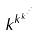<formula> <loc_0><loc_0><loc_500><loc_500>k ^ { k ^ { k ^ { \cdot ^ { \cdot ^ { \cdot } } } } }</formula> 